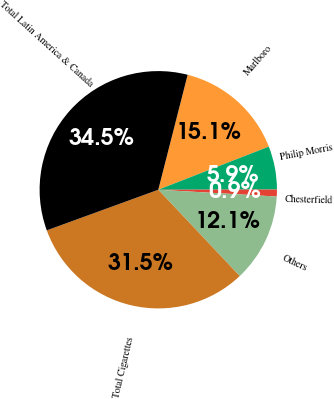Convert chart to OTSL. <chart><loc_0><loc_0><loc_500><loc_500><pie_chart><fcel>Marlboro<fcel>Philip Morris<fcel>Chesterfield<fcel>Others<fcel>Total Cigarettes<fcel>Total Latin America & Canada<nl><fcel>15.1%<fcel>5.89%<fcel>0.94%<fcel>12.05%<fcel>31.48%<fcel>34.54%<nl></chart> 